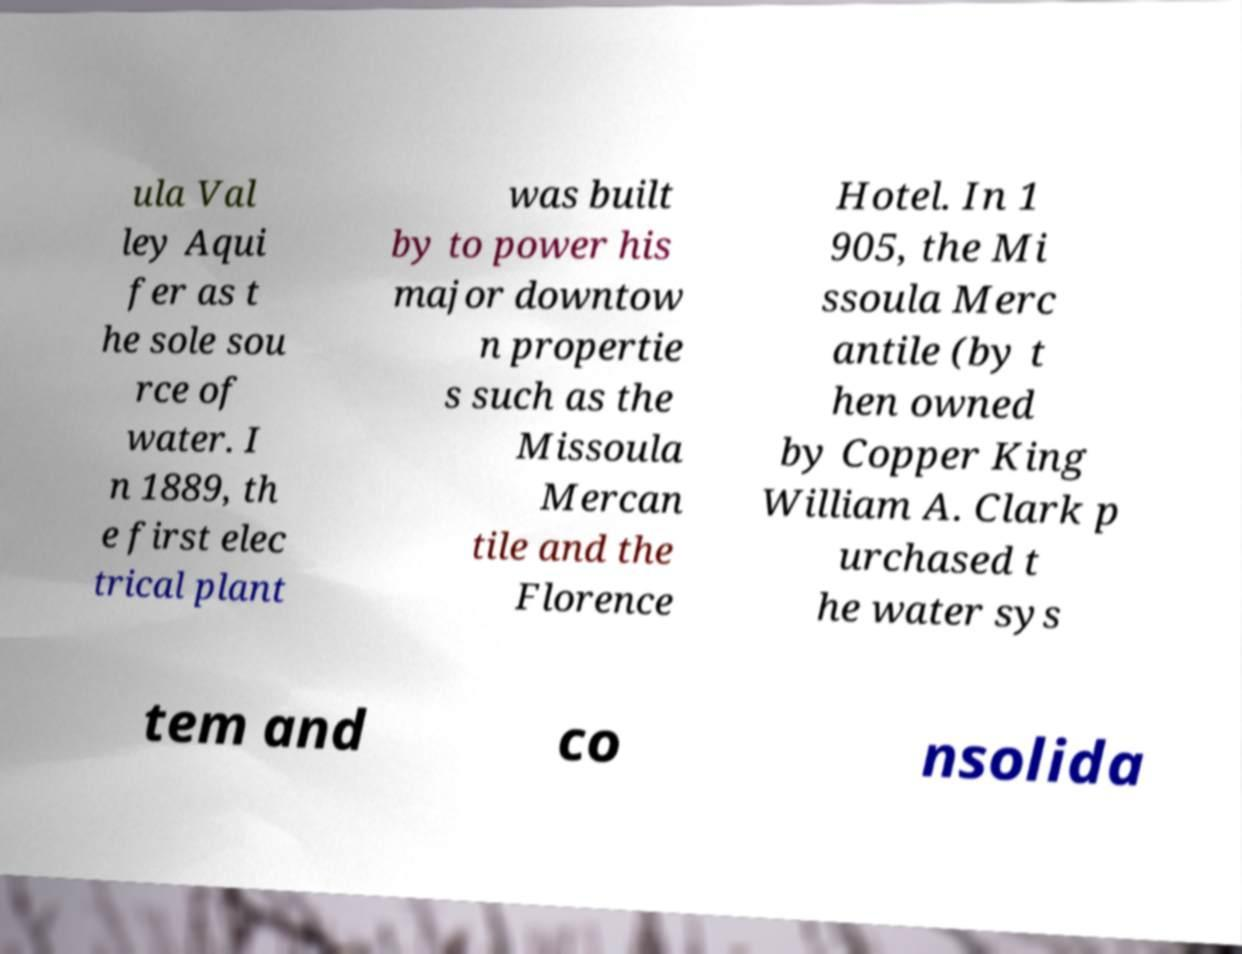Could you extract and type out the text from this image? ula Val ley Aqui fer as t he sole sou rce of water. I n 1889, th e first elec trical plant was built by to power his major downtow n propertie s such as the Missoula Mercan tile and the Florence Hotel. In 1 905, the Mi ssoula Merc antile (by t hen owned by Copper King William A. Clark p urchased t he water sys tem and co nsolida 